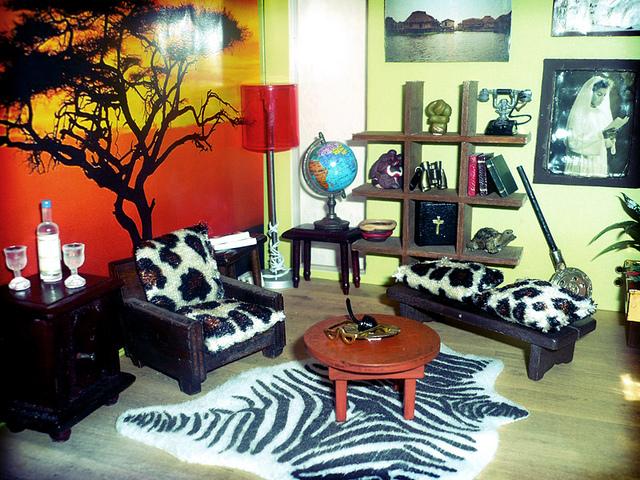Is there a picture of a wedding?
Keep it brief. Yes. Where is the sunset?
Concise answer only. On wall. What type of design is the rug?
Write a very short answer. Zebra. 